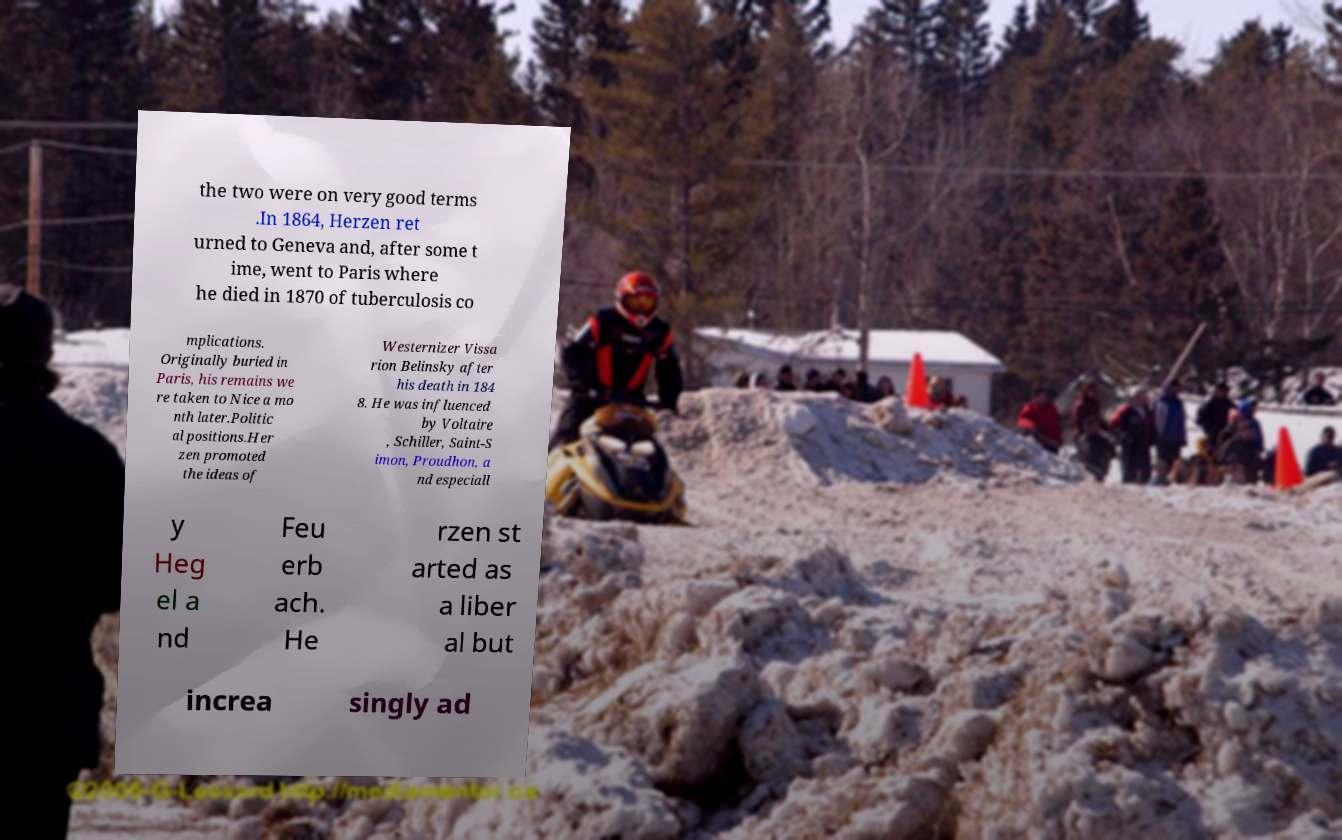Can you read and provide the text displayed in the image?This photo seems to have some interesting text. Can you extract and type it out for me? the two were on very good terms .In 1864, Herzen ret urned to Geneva and, after some t ime, went to Paris where he died in 1870 of tuberculosis co mplications. Originally buried in Paris, his remains we re taken to Nice a mo nth later.Politic al positions.Her zen promoted the ideas of Westernizer Vissa rion Belinsky after his death in 184 8. He was influenced by Voltaire , Schiller, Saint-S imon, Proudhon, a nd especiall y Heg el a nd Feu erb ach. He rzen st arted as a liber al but increa singly ad 